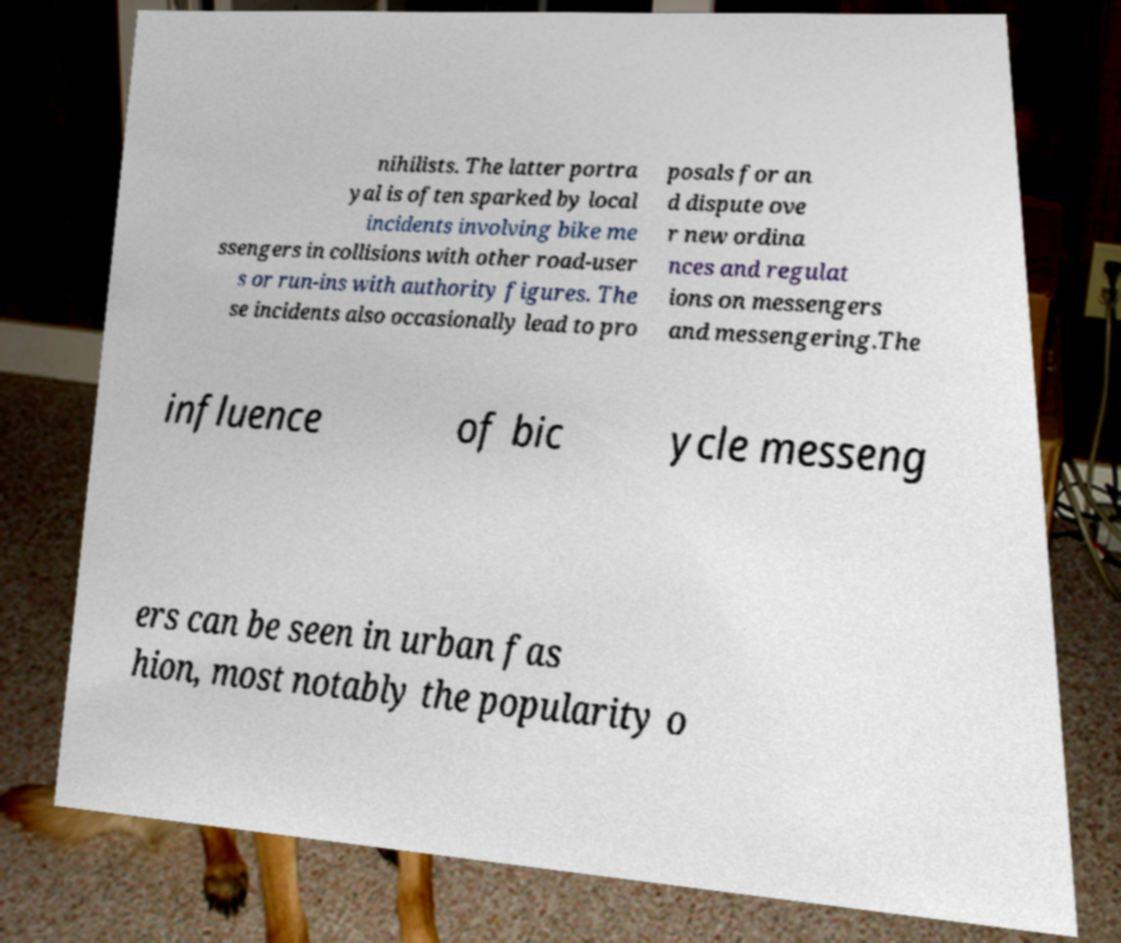There's text embedded in this image that I need extracted. Can you transcribe it verbatim? nihilists. The latter portra yal is often sparked by local incidents involving bike me ssengers in collisions with other road-user s or run-ins with authority figures. The se incidents also occasionally lead to pro posals for an d dispute ove r new ordina nces and regulat ions on messengers and messengering.The influence of bic ycle messeng ers can be seen in urban fas hion, most notably the popularity o 